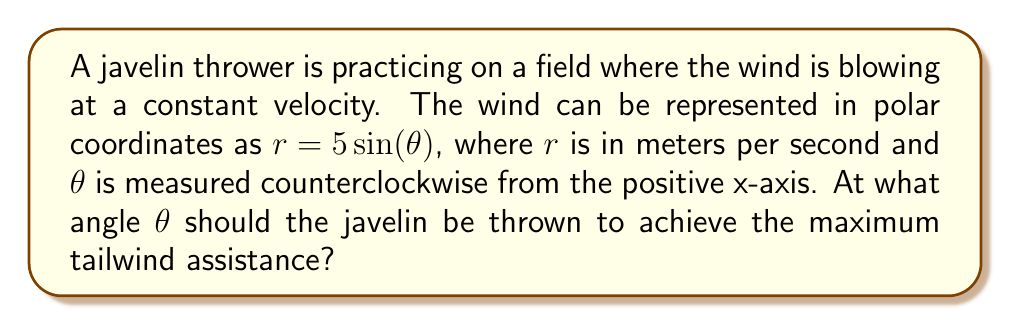Solve this math problem. To solve this problem, we need to find the maximum value of the function $r = 5\sin(\theta)$. This will give us the angle at which the wind speed is greatest in the direction of the throw.

1) The sine function reaches its maximum value of 1 when its argument is $\frac{\pi}{2}$ or 90°.

2) Therefore, we need to solve:
   $$5\sin(\theta) = 5$$
   
3) Dividing both sides by 5:
   $$\sin(\theta) = 1$$
   
4) The solution to this equation is:
   $$\theta = \frac{\pi}{2}$$ or 90°

5) To confirm this is a maximum and not a minimum, we can check the second derivative:
   $$\frac{d}{d\theta}(5\sin(\theta)) = 5\cos(\theta)$$
   $$\frac{d^2}{d\theta^2}(5\sin(\theta)) = -5\sin(\theta)$$
   
   At $\theta = \frac{\pi}{2}$, the second derivative is negative, confirming this is indeed a maximum.

6) In the context of javelin throwing, this means the optimal angle for the throw is 90° counterclockwise from the positive x-axis, or directly upward in a standard coordinate system.
Answer: The optimal angle for the javelin throw is $\theta = \frac{\pi}{2}$ radians or 90°. 